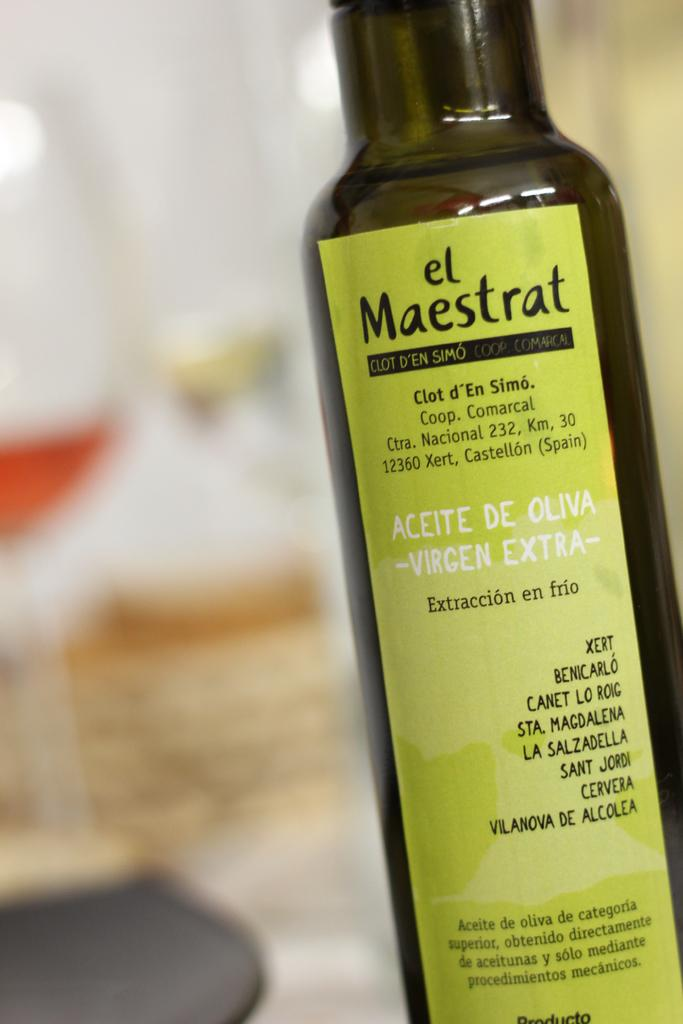What object can be seen in the image? There is a bottle in the image. Is there anything on the bottle? Yes, the bottle has a sticker on it. What type of haircut does the moon have in the image? The image does not contain a moon or any reference to a haircut. 